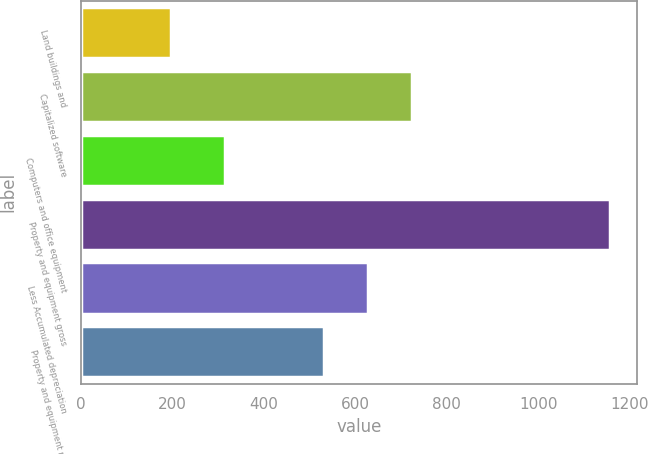Convert chart to OTSL. <chart><loc_0><loc_0><loc_500><loc_500><bar_chart><fcel>Land buildings and<fcel>Capitalized software<fcel>Computers and office equipment<fcel>Property and equipment gross<fcel>Less Accumulated depreciation<fcel>Property and equipment net<nl><fcel>197.3<fcel>723.38<fcel>315.9<fcel>1157.7<fcel>627.34<fcel>531.3<nl></chart> 